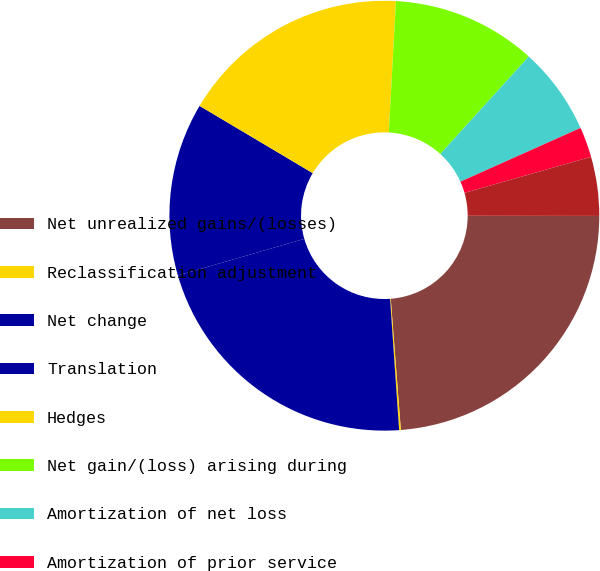Convert chart to OTSL. <chart><loc_0><loc_0><loc_500><loc_500><pie_chart><fcel>Net unrealized gains/(losses)<fcel>Reclassification adjustment<fcel>Net change<fcel>Translation<fcel>Hedges<fcel>Net gain/(loss) arising during<fcel>Amortization of net loss<fcel>Amortization of prior service<fcel>Foreign exchange and other<nl><fcel>23.76%<fcel>0.13%<fcel>21.61%<fcel>13.02%<fcel>17.32%<fcel>10.87%<fcel>6.58%<fcel>2.28%<fcel>4.43%<nl></chart> 